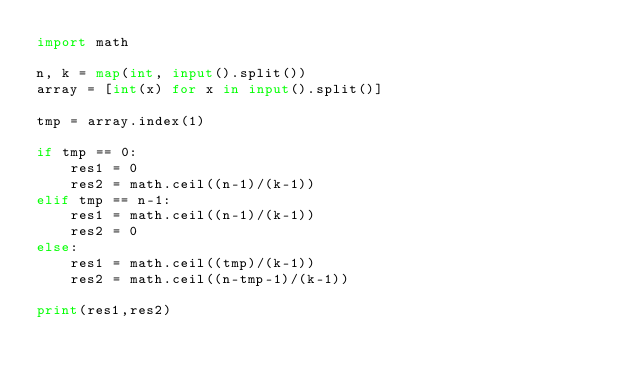<code> <loc_0><loc_0><loc_500><loc_500><_Python_>import math

n, k = map(int, input().split())
array = [int(x) for x in input().split()]

tmp = array.index(1)

if tmp == 0:
    res1 = 0
    res2 = math.ceil((n-1)/(k-1))
elif tmp == n-1:
    res1 = math.ceil((n-1)/(k-1))
    res2 = 0
else:
    res1 = math.ceil((tmp)/(k-1))
    res2 = math.ceil((n-tmp-1)/(k-1))

print(res1,res2)
</code> 